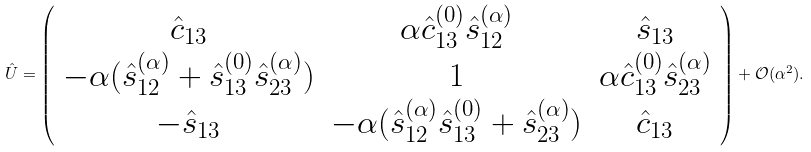<formula> <loc_0><loc_0><loc_500><loc_500>\hat { U } = \left ( \begin{array} { c c c } \hat { c } _ { 1 3 } & \alpha \hat { c } _ { 1 3 } ^ { ( 0 ) } \hat { s } _ { 1 2 } ^ { ( \alpha ) } & \hat { s } _ { 1 3 } \\ - \alpha ( \hat { s } _ { 1 2 } ^ { ( \alpha ) } + \hat { s } _ { 1 3 } ^ { ( 0 ) } \hat { s } _ { 2 3 } ^ { ( \alpha ) } ) & 1 & \alpha \hat { c } _ { 1 3 } ^ { ( 0 ) } \hat { s } _ { 2 3 } ^ { ( \alpha ) } \\ - \hat { s } _ { 1 3 } & - \alpha ( \hat { s } _ { 1 2 } ^ { ( \alpha ) } \hat { s } _ { 1 3 } ^ { ( 0 ) } + \hat { s } _ { 2 3 } ^ { ( \alpha ) } ) & \hat { c } _ { 1 3 } \end{array} \right ) + \mathcal { O } ( \alpha ^ { 2 } ) .</formula> 